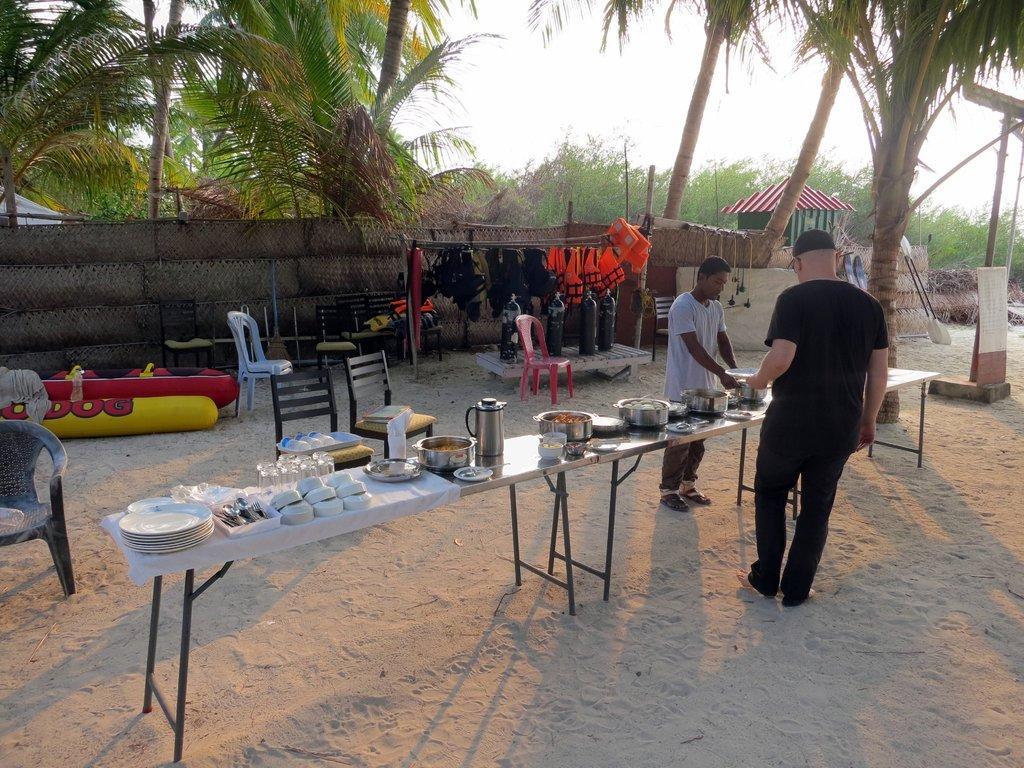Describe this image in one or two sentences. In this image, I can see two people standing. There are tables with plates, bowls, glasses, utensils and few other objects. I can see the chairs and life jackets hanging to a hanger. In the background, there are trees and the sky. On the right side of the image, I can see the paddles and a board. 